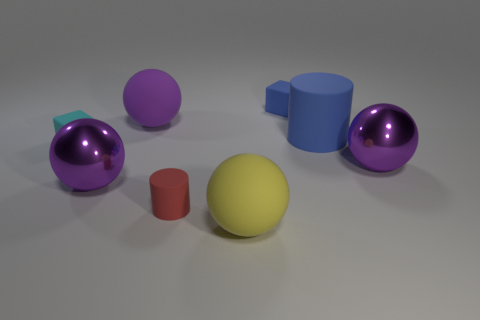There is a object that is the same color as the big matte cylinder; what is its shape?
Offer a very short reply. Cube. Are there more large metallic objects that are in front of the large blue matte cylinder than yellow rubber things that are left of the purple matte object?
Your response must be concise. Yes. There is a matte sphere behind the red object; is it the same color as the small cylinder?
Offer a terse response. No. Is there any other thing that has the same color as the big matte cylinder?
Offer a terse response. Yes. Are there more large yellow matte balls that are in front of the small cyan thing than large cyan balls?
Your answer should be compact. Yes. Is the size of the red cylinder the same as the yellow rubber ball?
Your answer should be very brief. No. How many brown objects are large metallic things or small things?
Offer a very short reply. 0. What material is the sphere that is behind the big blue matte cylinder?
Provide a short and direct response. Rubber. Is the number of blue matte things greater than the number of small green blocks?
Ensure brevity in your answer.  Yes. There is a blue object that is in front of the tiny blue rubber object; does it have the same shape as the red rubber object?
Your answer should be compact. Yes. 